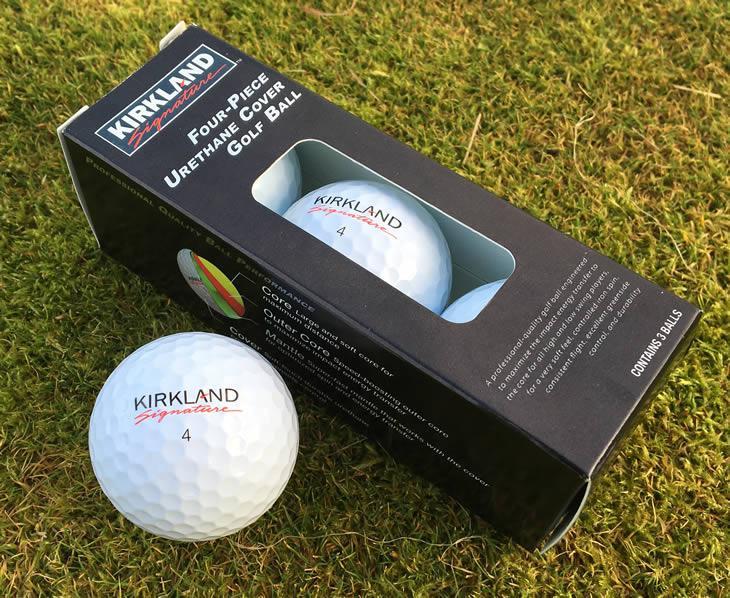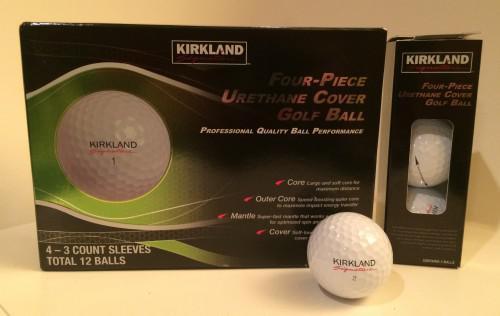The first image is the image on the left, the second image is the image on the right. Assess this claim about the two images: "At least one image includes a golf ball that is not in a package in front of golf balls in a package.". Correct or not? Answer yes or no. Yes. The first image is the image on the left, the second image is the image on the right. Examine the images to the left and right. Is the description "Two golf balls are not in a box." accurate? Answer yes or no. Yes. 